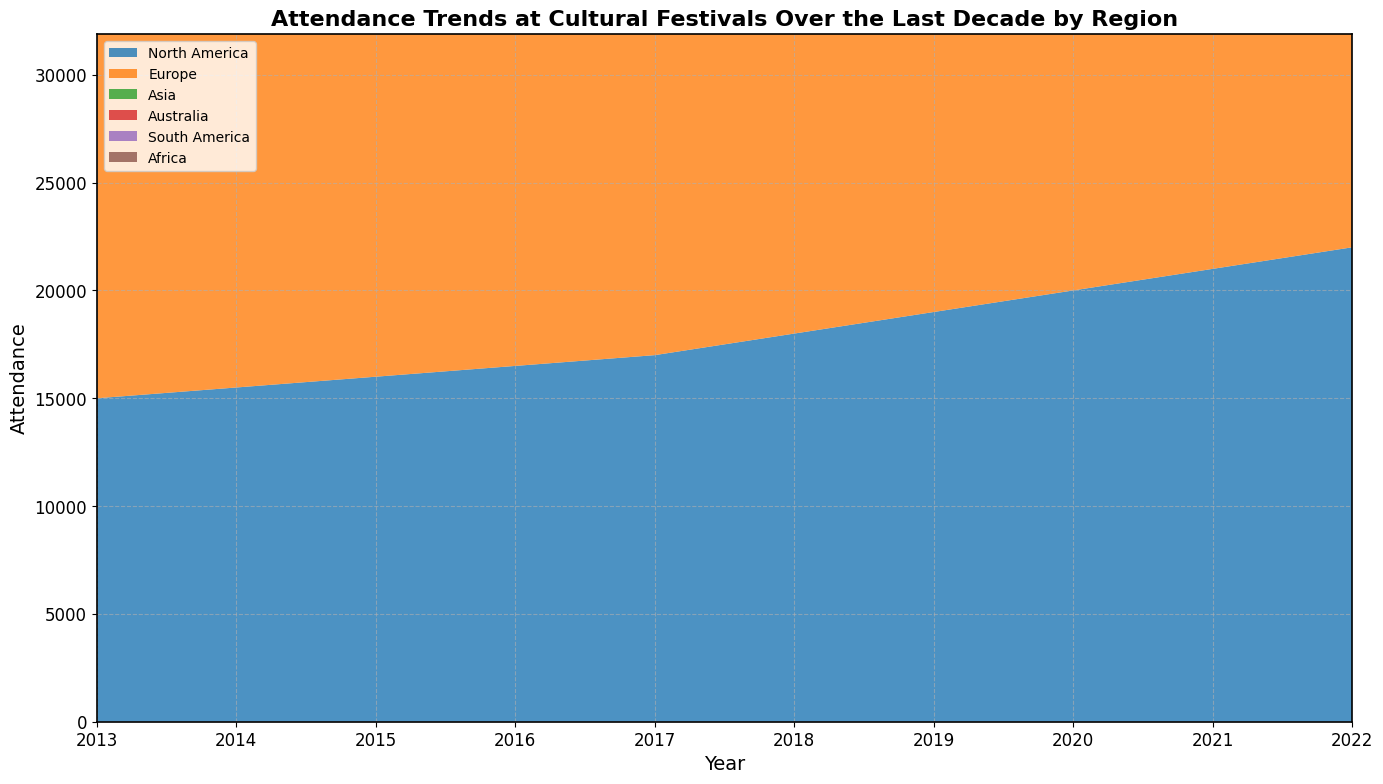Which region had the highest attendance in 2022? From the chart, it's evident that the region with the tallest area segment in 2022 indicates the highest attendance, which corresponds to Europe.
Answer: Europe How did the attendance in North America change from 2013 to 2022? The chart shows that the area representing North America increased steadily over the years. By subtracting the value in 2013 (15,000) from the value in 2022 (22,000), the increase in attendance is calculated. 22,000 - 15,000 = 7,000.
Answer: Increased by 7,000 Compare the trends of Asia and South America from 2013 to 2022. Visually, the areas for both regions have grown over the years. However, Asia experienced a more significant increase in attendance compared to South America. Asia's attendance grew from 8,000 to 12,500 (an increase of 4,500), while South America's attendance grew from 4,500 to 5,400 (an increase of 900). 4,500 (Asia) > 900 (South America).
Answer: Asia's trend is more significant than South America's Which region showed the most consistent increase in attendance over the decade? Observing the chart, Europe shows a smooth upward trend without any dips, indicating a consistent increase in attendance each year.
Answer: Europe What is the average annual attendance for Australia over the decade? Sum up Australia's attendances from 2013 to 2022: 5,000 + 5,200 + 5,400 + 5,600 + 5,800 + 6,000 + 6,200 + 6,400 + 6,600 + 6,800 = 58,000. Then, divide this by 10 (the number of years). 58,000 / 10 = 5,800.
Answer: 5,800 How does the attendance in Africa in 2022 compare to that in 2013? The chart shows that Africa's attendance grew modestly from 3,000 in 2013 to 3,900 in 2022. By calculating 3,900 - 3,000, the result is 900, indicating an increase of 900.
Answer: Increased by 900 Which two regions had the smallest difference in attendance in 2020? By comparing the areas in 2020, South America and Africa appear closest in size. South America had 5,200 attendees and Africa had 3,700. The difference is 5,200 - 3,700 = 1,500, which is smaller compared to other region pairs.
Answer: South America and Africa What's the combined attendance of all regions in 2019? Add the number of attendees in each region for 2019: 19,000 (North America) + 27,000 (Europe) + 11,000 (Asia) + 6,200 (Australia) + 5,100 (South America) + 3,600 (Africa) = 71,900.
Answer: 71,900 Which region had the lowest attendance in 2017, and what was the value? From the chart, Africa has the smallest area segment in 2017, indicating the lowest attendance, which is 3,400.
Answer: Africa, 3,400 